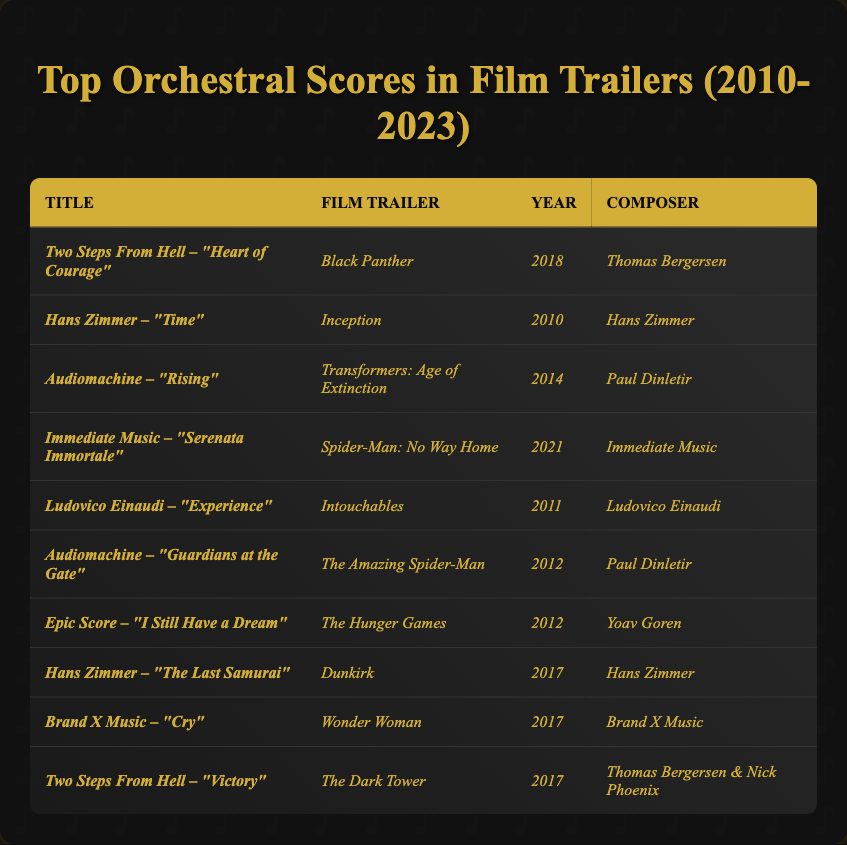What is the title of the orchestral score used in the *Black Panther* trailer? The title listed next to the *Black Panther* trailer is *Two Steps From Hell – "Heart of Courage"*.
Answer: *Two Steps From Hell – "Heart of Courage"* Who composed the score for *Inception*? The composer listed for *Inception* is Hans Zimmer.
Answer: Hans Zimmer How many film trailers are featured in the table from the year 2017? There are three trailers listed from the year 2017: *Dunkirk*, *Wonder Woman*, and *The Dark Tower*.
Answer: 3 Which composer has multiple works listed in the table? Two composers have multiple works: Hans Zimmer is mentioned for both *Inception* and *Dunkirk*, and Thomas Bergersen is credited for *Heart of Courage* and *Victory*.
Answer: Hans Zimmer and Thomas Bergersen Which film trailer released in 2012 corresponds to the score titled *"I Still Have a Dream"*? The trailer for *The Hunger Games* corresponds to the score *"I Still Have a Dream"*, and it is listed under the year 2012.
Answer: *The Hunger Games* What is the average year of the film trailers listed in the table? The years of the listed trailers are: 2010, 2011, 2012, 2012, 2014, 2017, 2017, 2017, and 2018. Adding them gives 2010 + 2011 + 2012 + 2012 + 2014 + 2017 + 2017 + 2017 + 2018 = 1814. There are 9 entries, so average year is 1814 / 9 = 201.56, which is roughly 2017.
Answer: 2017 Is it true that *Audiomachine* composed the score for *Spider-Man: No Way Home*? No, *Immediate Music* composed the score for *Spider-Man: No Way Home* as per the table.
Answer: No What year did the score *"Experience"* by Ludovico Einaudi appear, and which film was it used for? The score *"Experience"* appeared in 2011 and was used for *Intouchables*.
Answer: 2011, *Intouchables* How many scores by *Two Steps From Hell* are listed? There are two scores by *Two Steps From Hell* listed: *"Heart of Courage"* and *"Victory"*.
Answer: 2 Which score listed is attributed to *Paul Dinletir*? The scores attributed to *Paul Dinletir* are *"Rising"* for *Transformers: Age of Extinction* and *"Guardians at the Gate"* for *The Amazing Spider-Man*.
Answer: *"Rising"* and *"Guardians at the Gate"* 